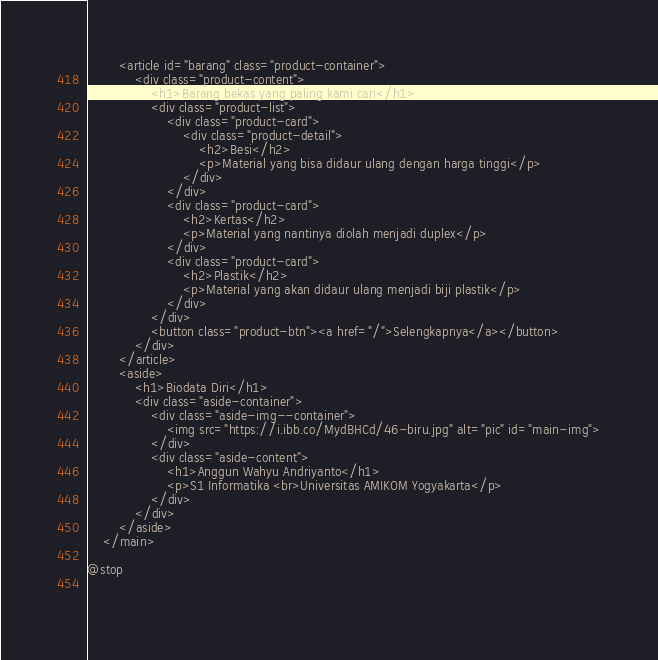<code> <loc_0><loc_0><loc_500><loc_500><_PHP_>        <article id="barang" class="product-container">
            <div class="product-content">
                <h1>Barang bekas yang paling kami cari</h1>
                <div class="product-list">
                    <div class="product-card">
                        <div class="product-detail">
                            <h2>Besi</h2>
                            <p>Material yang bisa didaur ulang dengan harga tinggi</p>
                        </div>
                    </div>
                    <div class="product-card">
                        <h2>Kertas</h2>
                        <p>Material yang nantinya diolah menjadi duplex</p>
                    </div>
                    <div class="product-card">
                        <h2>Plastik</h2>
                        <p>Material yang akan didaur ulang menjadi biji plastik</p>
                    </div>
                </div>
                <button class="product-btn"><a href="/">Selengkapnya</a></button>
            </div>
        </article>
        <aside>
            <h1>Biodata Diri</h1>
            <div class="aside-container">
                <div class="aside-img--container">
                    <img src="https://i.ibb.co/MydBHCd/46-biru.jpg" alt="pic" id="main-img">
                </div>
                <div class="aside-content">
                    <h1>Anggun Wahyu Andriyanto</h1>
                    <p>S1 Informatika <br>Universitas AMIKOM Yogyakarta</p>
                </div>
            </div>
        </aside>
    </main>

@stop
    
    </code> 